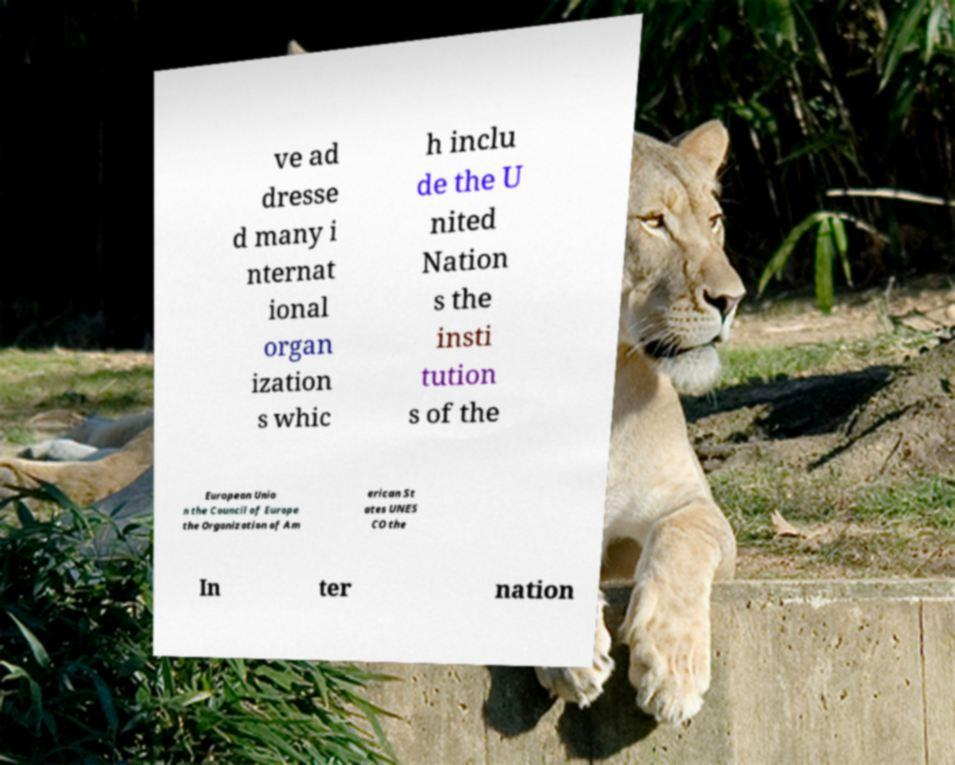What messages or text are displayed in this image? I need them in a readable, typed format. ve ad dresse d many i nternat ional organ ization s whic h inclu de the U nited Nation s the insti tution s of the European Unio n the Council of Europe the Organization of Am erican St ates UNES CO the In ter nation 